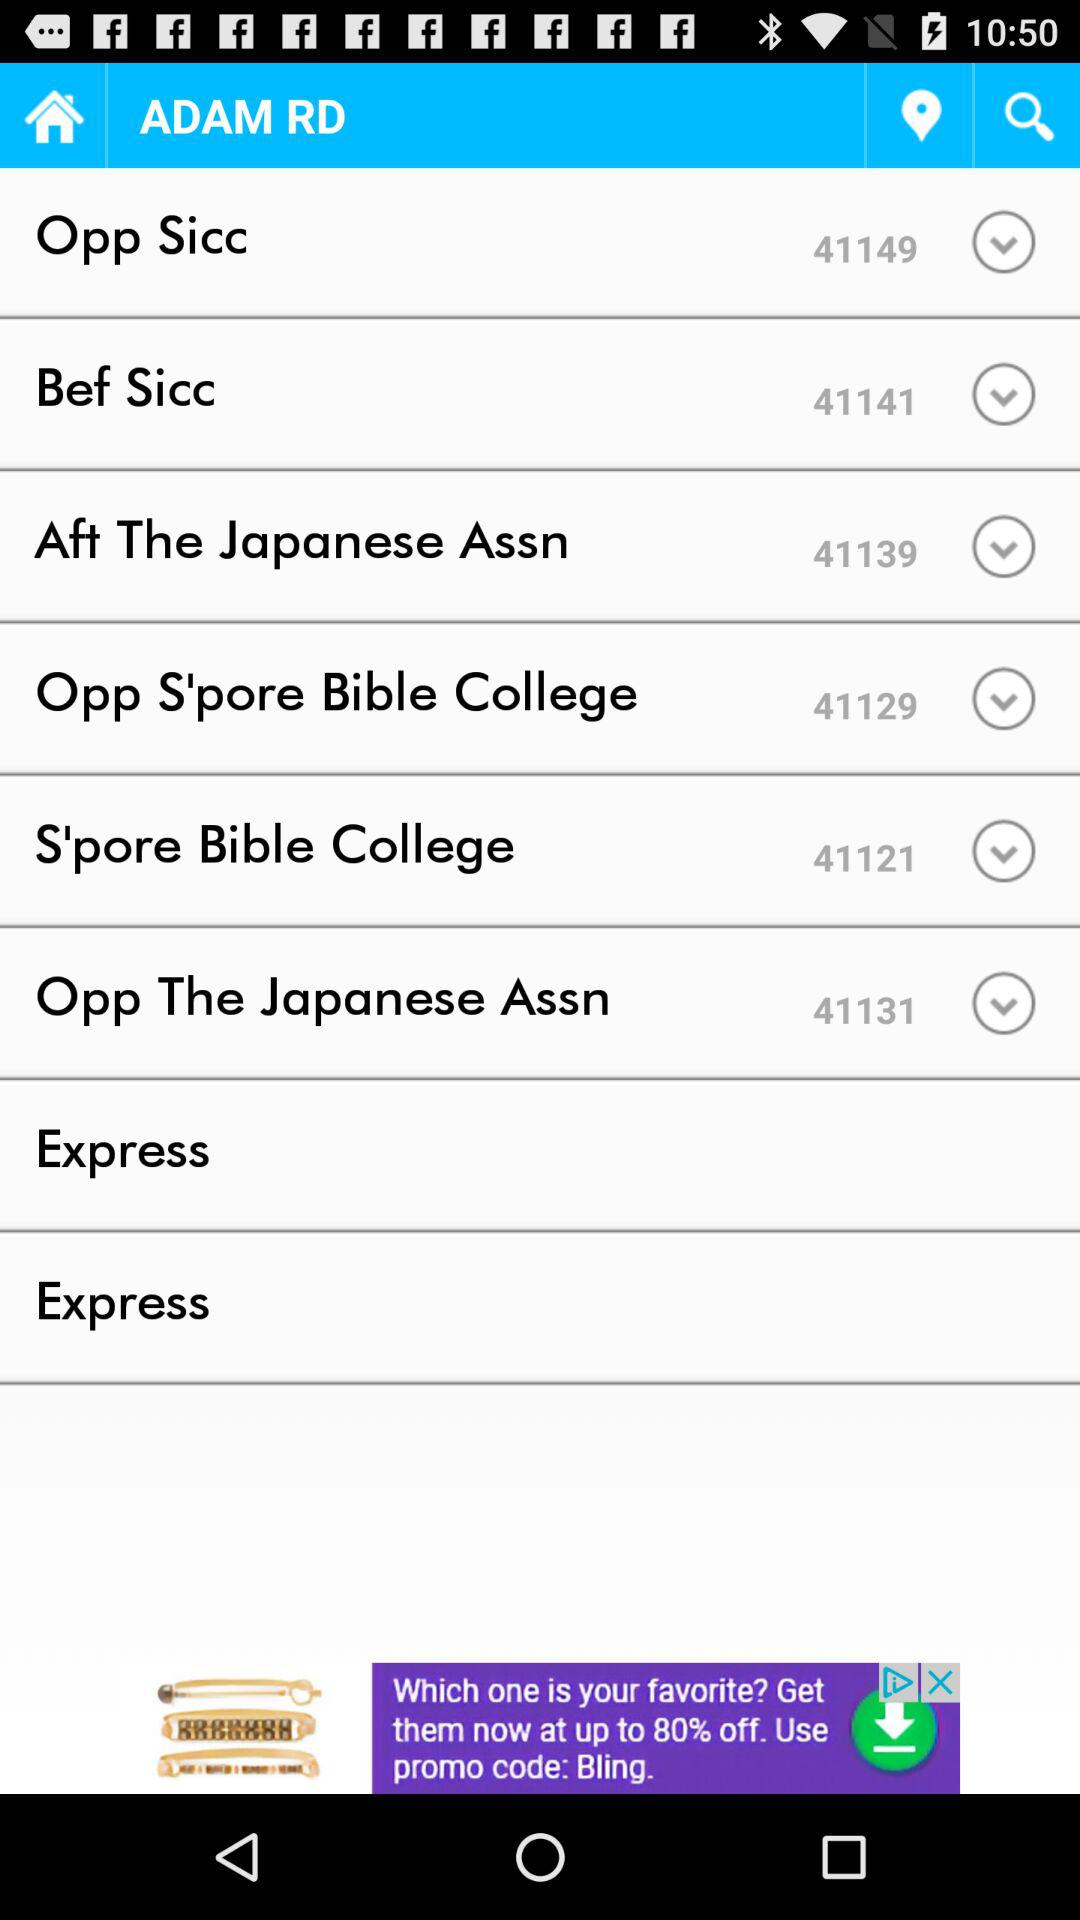What is the ID given for "Opp Sicc"? The ID given for "Opp Sicc" is 41149. 